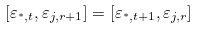<formula> <loc_0><loc_0><loc_500><loc_500>[ \varepsilon _ { ^ { * } , t } , \varepsilon _ { j , r + 1 } ] = [ \varepsilon _ { ^ { * } , t + 1 } , \varepsilon _ { j , r } ]</formula> 